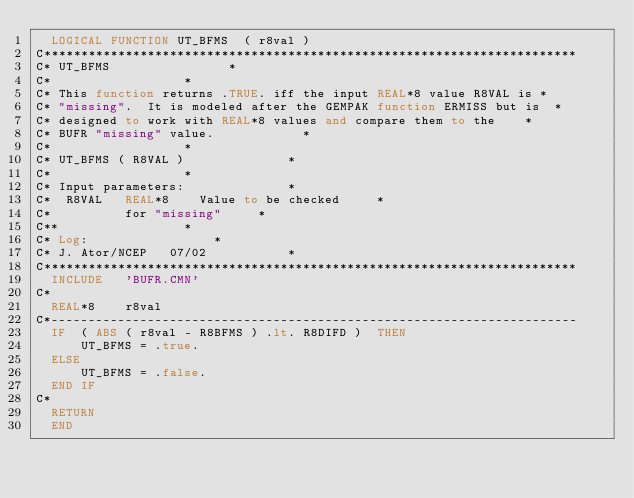Convert code to text. <code><loc_0><loc_0><loc_500><loc_500><_FORTRAN_>	LOGICAL FUNCTION UT_BFMS  ( r8val )
C************************************************************************
C* UT_BFMS								*
C*									*
C* This function returns .TRUE. iff the input REAL*8 value R8VAL is	*
C* "missing".  It is modeled after the GEMPAK function ERMISS but is	*
C* designed to work with REAL*8 values and compare them to the		*
C* BUFR "missing" value.						*
C*									*
C* UT_BFMS ( R8VAL )							*
C*									*
C* Input parameters:							*
C*	R8VAL		REAL*8		Value to be checked 		*
C*					for "missing"			*
C**									*
C* Log:									*
C* J. Ator/NCEP		07/02						*
C************************************************************************
	INCLUDE		'BUFR.CMN'
C*
	REAL*8		r8val
C*-----------------------------------------------------------------------
	IF  ( ABS ( r8val - R8BFMS ) .lt. R8DIFD )  THEN
	    UT_BFMS = .true.
	ELSE
	    UT_BFMS = .false.
	END IF
C*
	RETURN
	END
</code> 